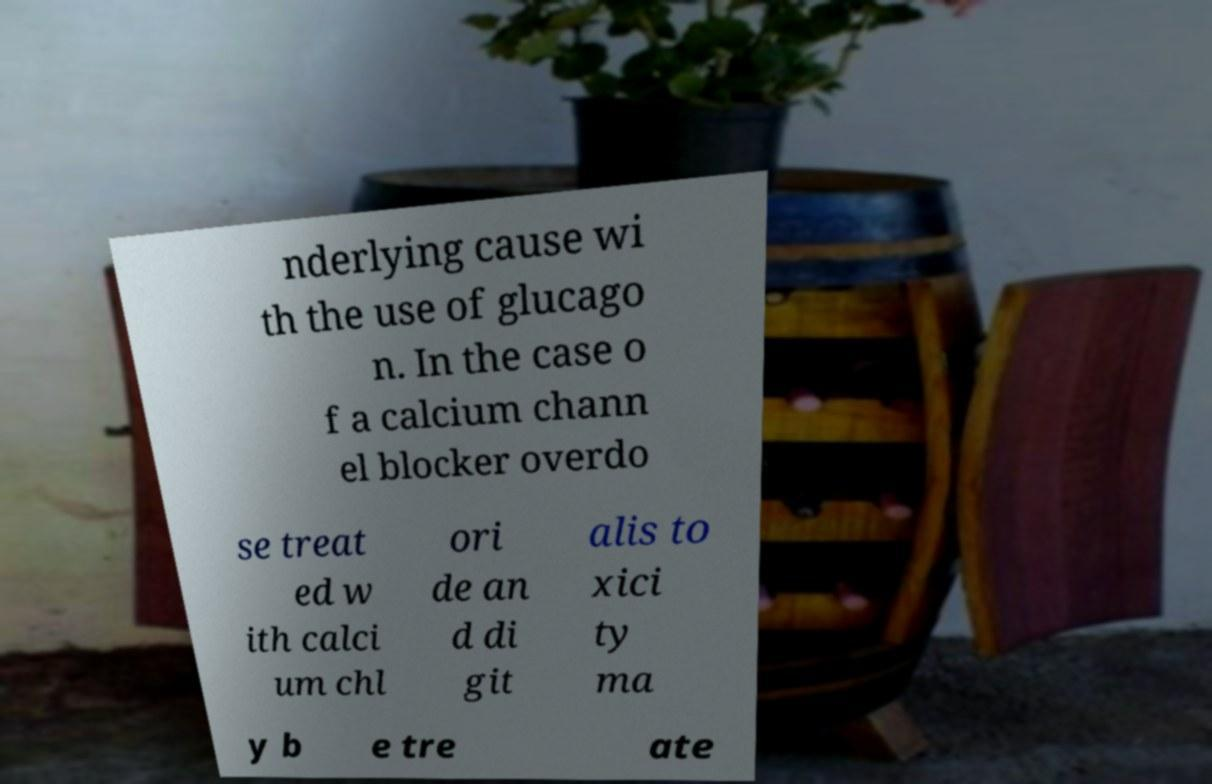For documentation purposes, I need the text within this image transcribed. Could you provide that? nderlying cause wi th the use of glucago n. In the case o f a calcium chann el blocker overdo se treat ed w ith calci um chl ori de an d di git alis to xici ty ma y b e tre ate 